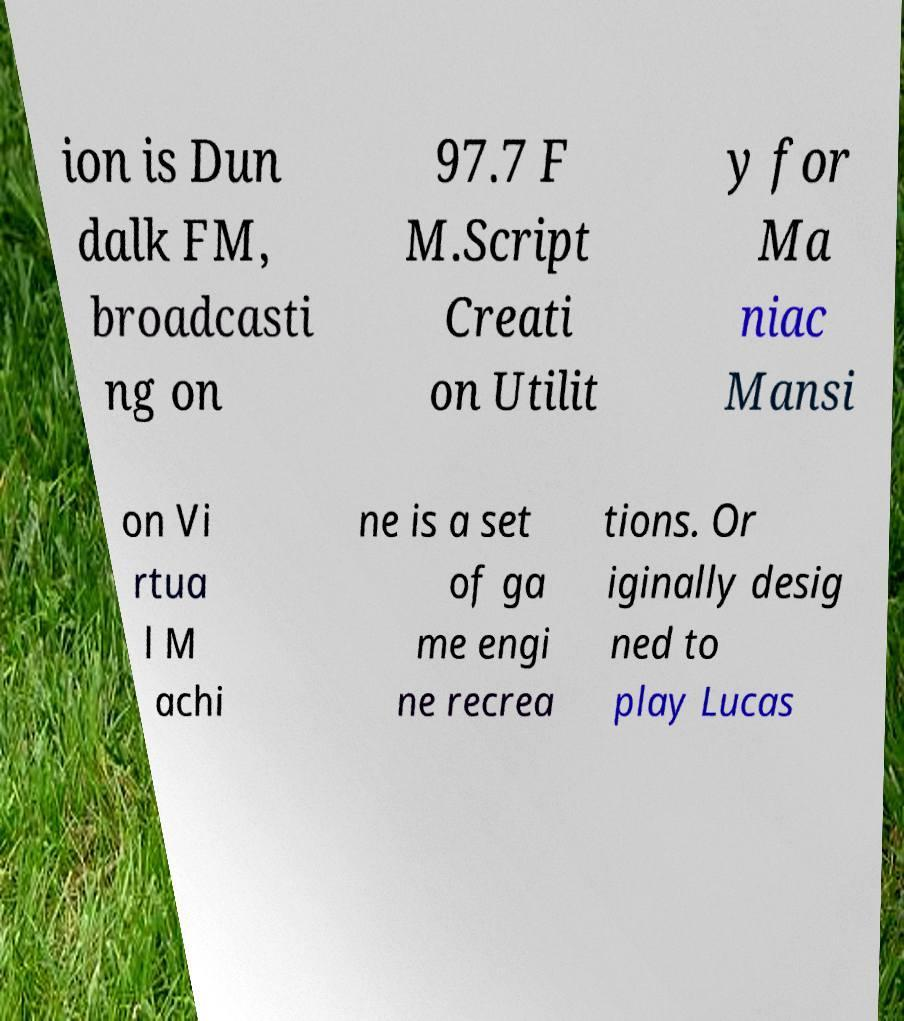For documentation purposes, I need the text within this image transcribed. Could you provide that? ion is Dun dalk FM, broadcasti ng on 97.7 F M.Script Creati on Utilit y for Ma niac Mansi on Vi rtua l M achi ne is a set of ga me engi ne recrea tions. Or iginally desig ned to play Lucas 